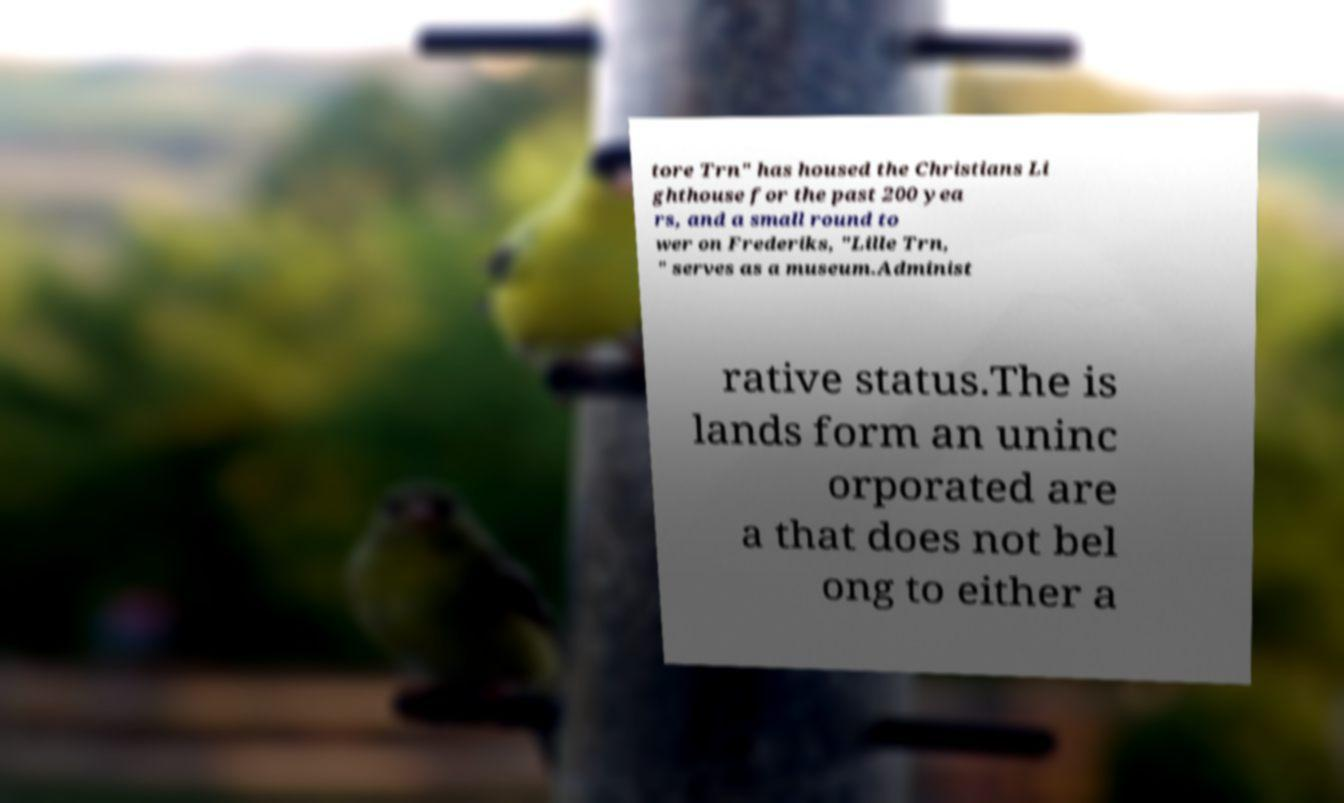There's text embedded in this image that I need extracted. Can you transcribe it verbatim? tore Trn" has housed the Christians Li ghthouse for the past 200 yea rs, and a small round to wer on Frederiks, "Lille Trn, " serves as a museum.Administ rative status.The is lands form an uninc orporated are a that does not bel ong to either a 